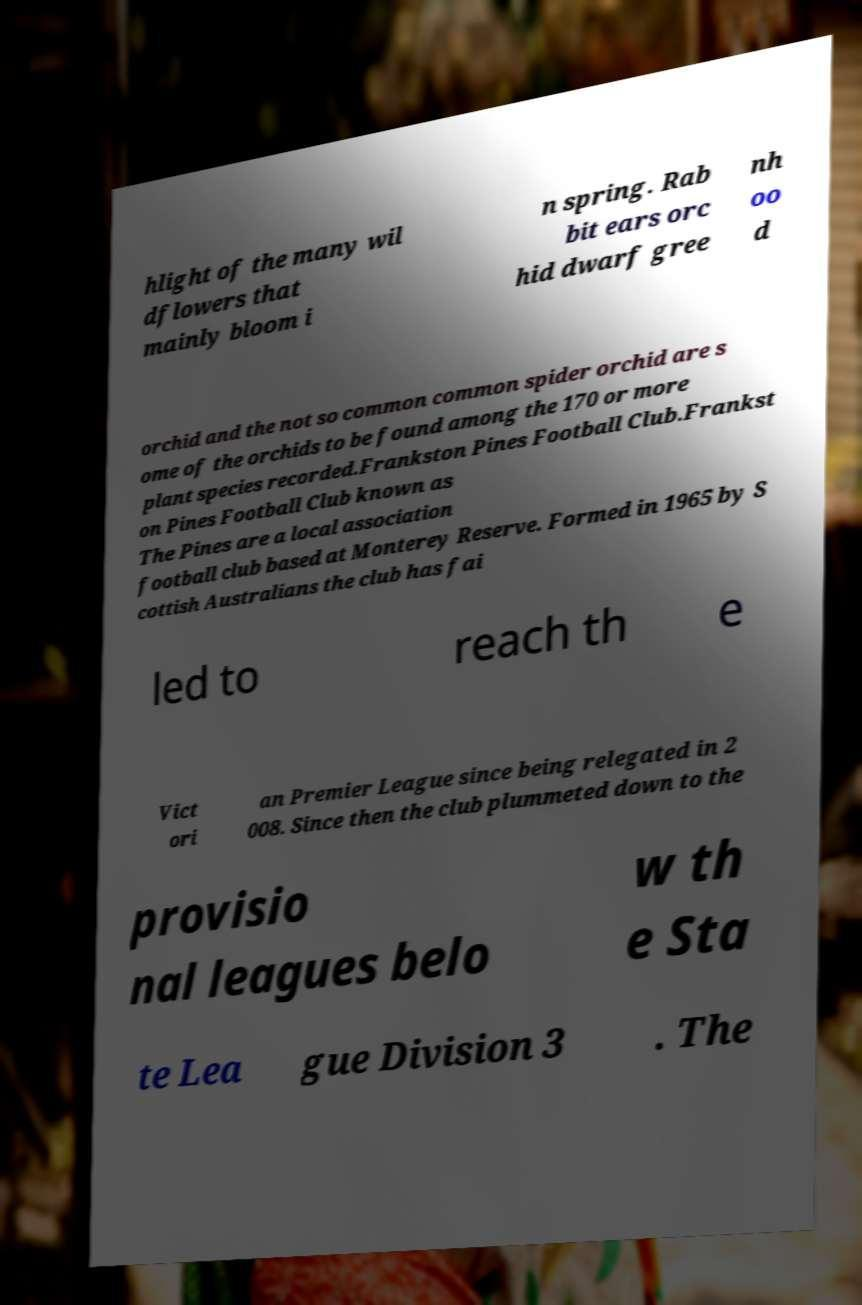Please read and relay the text visible in this image. What does it say? hlight of the many wil dflowers that mainly bloom i n spring. Rab bit ears orc hid dwarf gree nh oo d orchid and the not so common common spider orchid are s ome of the orchids to be found among the 170 or more plant species recorded.Frankston Pines Football Club.Frankst on Pines Football Club known as The Pines are a local association football club based at Monterey Reserve. Formed in 1965 by S cottish Australians the club has fai led to reach th e Vict ori an Premier League since being relegated in 2 008. Since then the club plummeted down to the provisio nal leagues belo w th e Sta te Lea gue Division 3 . The 